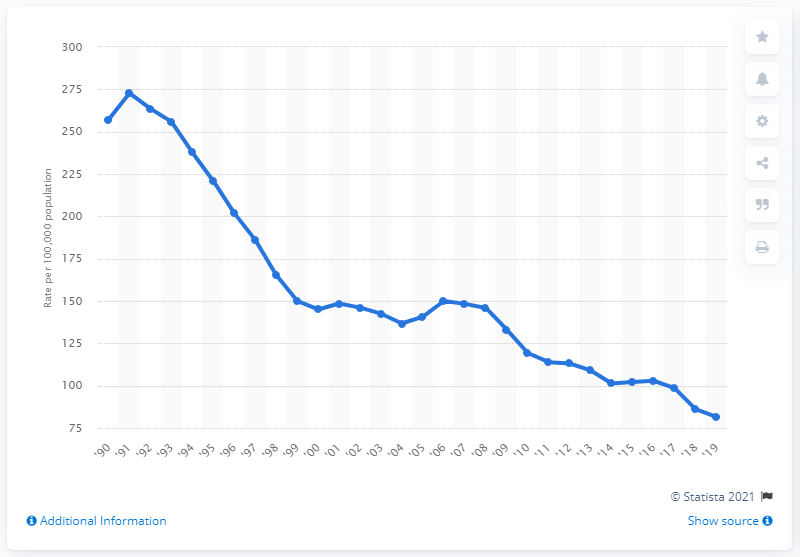Outline some significant characteristics in this image. According to data from 2019, the nationwide rate of robbery per 100,000 of the population was 81.6. 